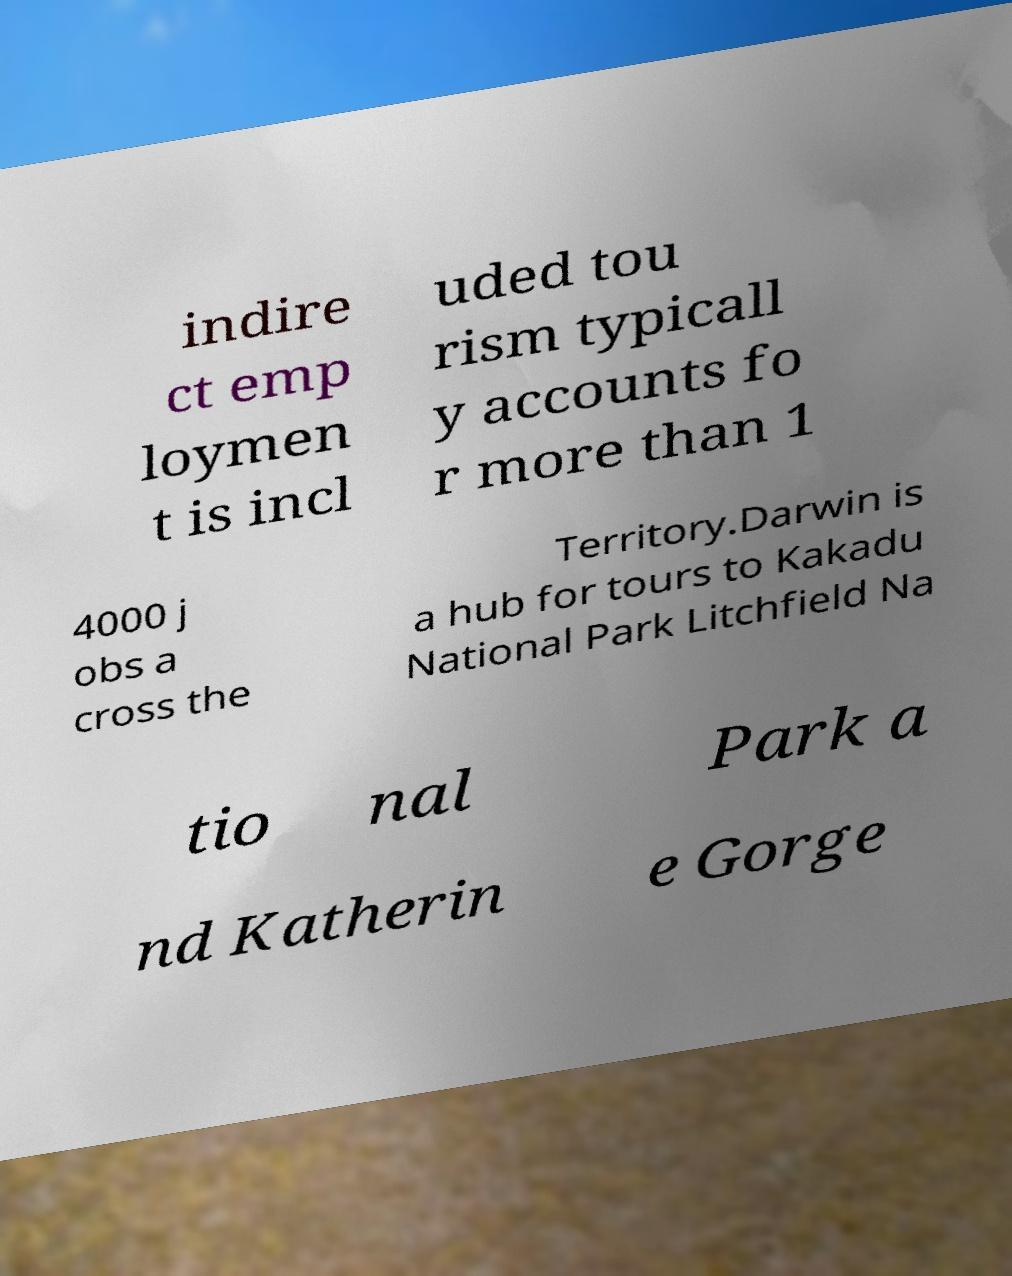Could you extract and type out the text from this image? indire ct emp loymen t is incl uded tou rism typicall y accounts fo r more than 1 4000 j obs a cross the Territory.Darwin is a hub for tours to Kakadu National Park Litchfield Na tio nal Park a nd Katherin e Gorge 